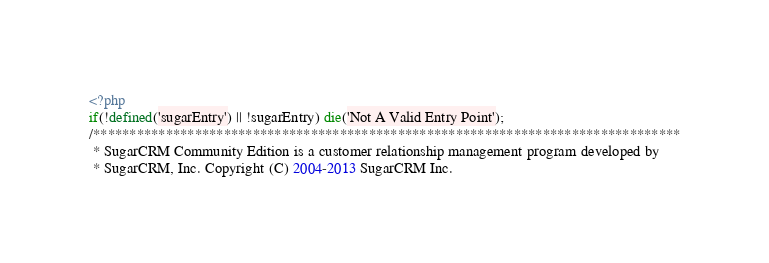<code> <loc_0><loc_0><loc_500><loc_500><_PHP_><?php
if(!defined('sugarEntry') || !sugarEntry) die('Not A Valid Entry Point');
/*********************************************************************************
 * SugarCRM Community Edition is a customer relationship management program developed by
 * SugarCRM, Inc. Copyright (C) 2004-2013 SugarCRM Inc.
</code> 